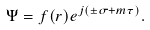Convert formula to latex. <formula><loc_0><loc_0><loc_500><loc_500>\Psi = f ( r ) e ^ { j ( \pm \sigma + m \tau ) } .</formula> 